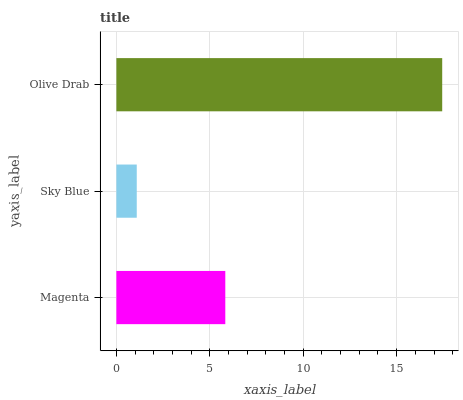Is Sky Blue the minimum?
Answer yes or no. Yes. Is Olive Drab the maximum?
Answer yes or no. Yes. Is Olive Drab the minimum?
Answer yes or no. No. Is Sky Blue the maximum?
Answer yes or no. No. Is Olive Drab greater than Sky Blue?
Answer yes or no. Yes. Is Sky Blue less than Olive Drab?
Answer yes or no. Yes. Is Sky Blue greater than Olive Drab?
Answer yes or no. No. Is Olive Drab less than Sky Blue?
Answer yes or no. No. Is Magenta the high median?
Answer yes or no. Yes. Is Magenta the low median?
Answer yes or no. Yes. Is Olive Drab the high median?
Answer yes or no. No. Is Olive Drab the low median?
Answer yes or no. No. 